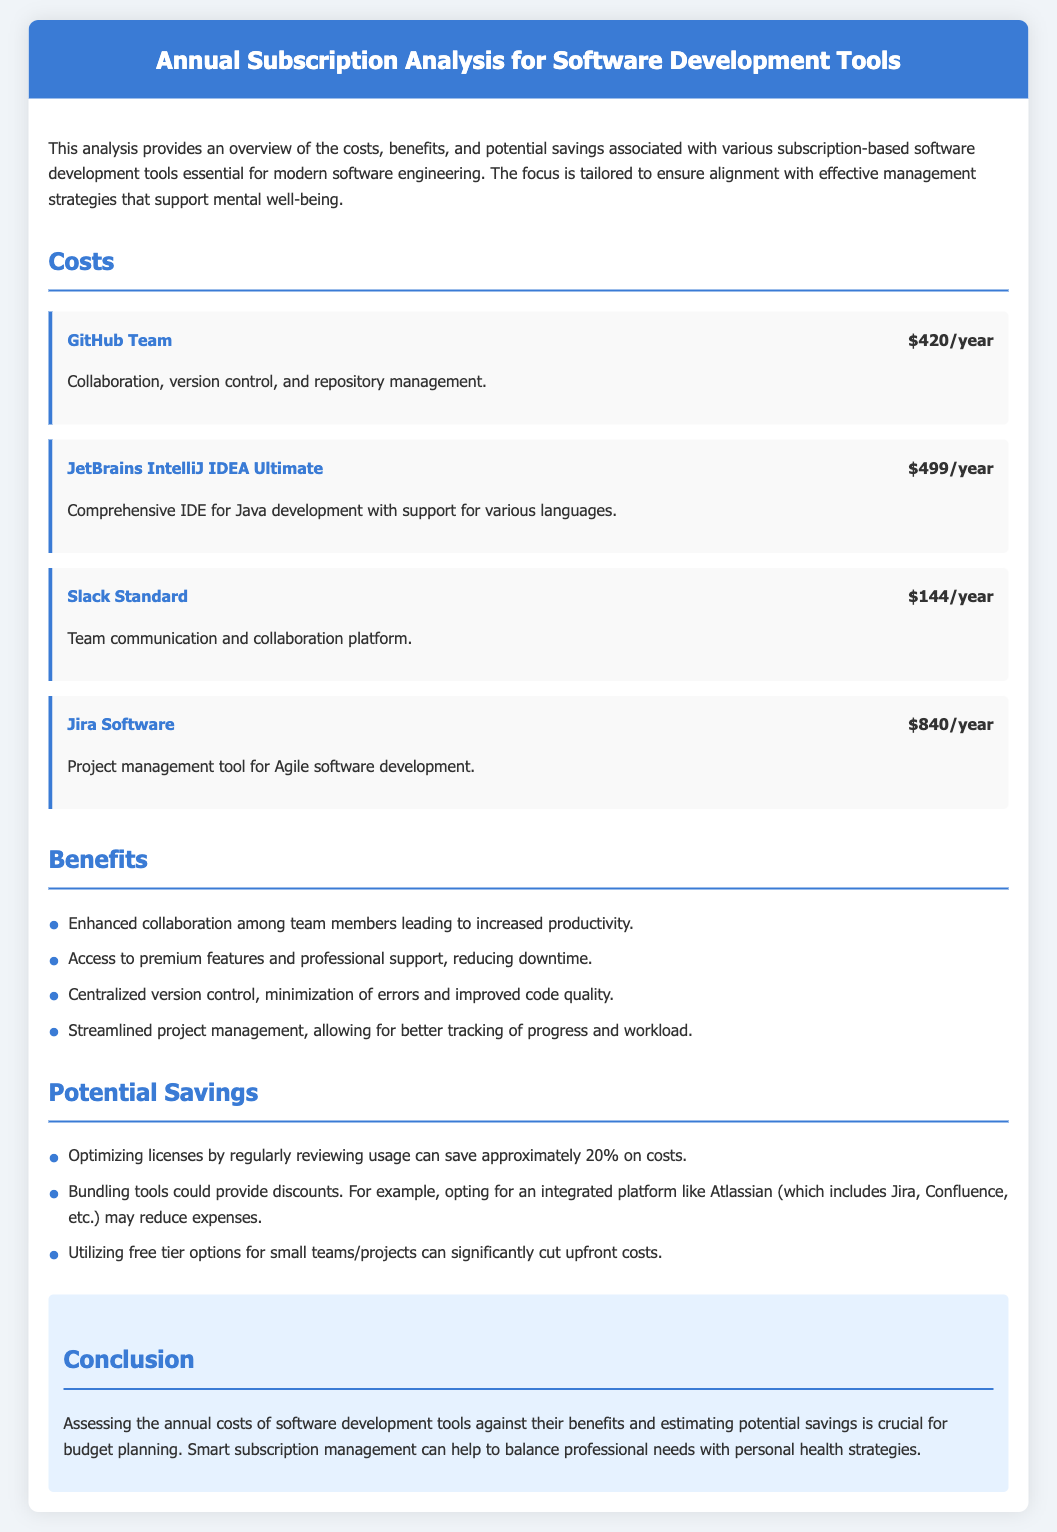What is the cost of GitHub Team? The cost of GitHub Team is explicitly mentioned in the document as $420/year.
Answer: $420/year What is the primary purpose of Jira Software? The document states that Jira Software is a project management tool for Agile software development.
Answer: Project management tool for Agile software development How much does JetBrains IntelliJ IDEA Ultimate cost? The cost of JetBrains IntelliJ IDEA Ultimate is provided as $499/year in the document.
Answer: $499/year What percentage of savings can be achieved by optimizing licenses? The document mentions that regularly reviewing usage can save approximately 20% on costs.
Answer: 20% What is one of the benefits of using the listed software development tools? The document lists enhanced collaboration among team members as a benefit.
Answer: Enhanced collaboration What type of platform is Slack? Slack is described in the document as a team communication and collaboration platform.
Answer: Team communication and collaboration platform What is one potential way to reduce expenses mentioned in the analysis? The document suggests that bundling tools could provide discounts to reduce expenses.
Answer: Bundling tools What is the conclusion about managing software tool subscriptions? The conclusion emphasizes that assessing costs against benefits is crucial for budget planning.
Answer: Assessing costs against benefits is crucial for budget planning 